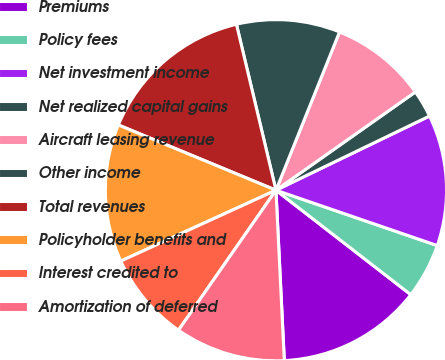<chart> <loc_0><loc_0><loc_500><loc_500><pie_chart><fcel>Premiums<fcel>Policy fees<fcel>Net investment income<fcel>Net realized capital gains<fcel>Aircraft leasing revenue<fcel>Other income<fcel>Total revenues<fcel>Policyholder benefits and<fcel>Interest credited to<fcel>Amortization of deferred<nl><fcel>13.73%<fcel>5.23%<fcel>12.42%<fcel>2.61%<fcel>9.15%<fcel>9.8%<fcel>15.03%<fcel>13.07%<fcel>8.5%<fcel>10.46%<nl></chart> 